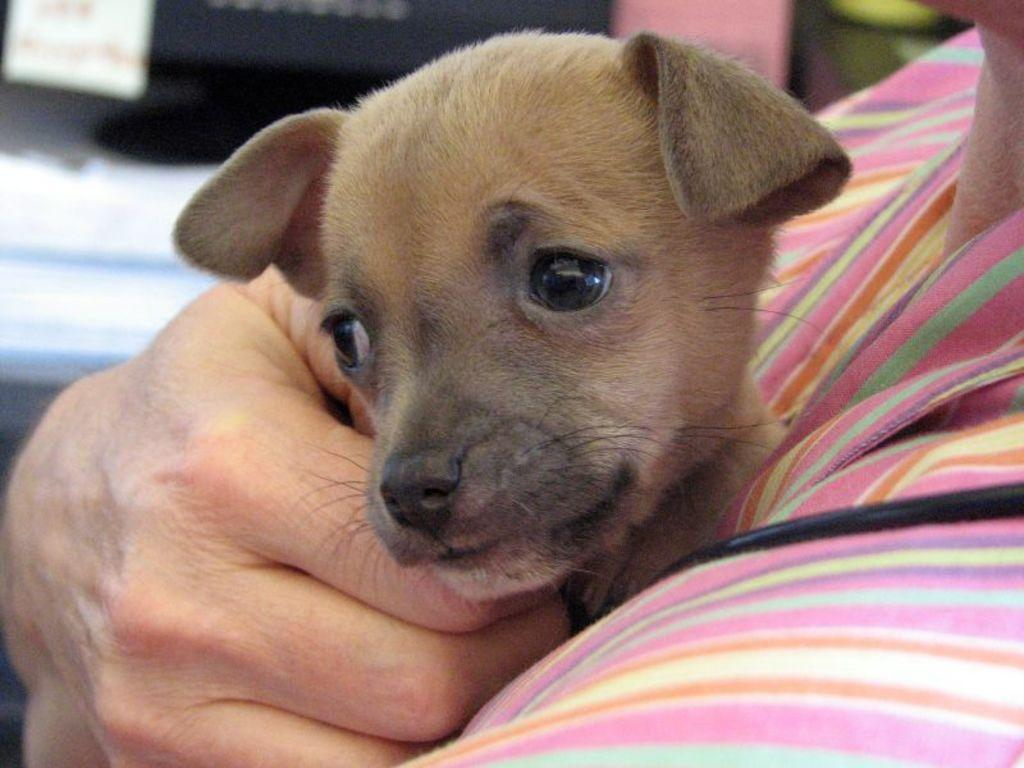What is the main subject of the image? There is a person in the image. What is the person doing in the image? The person is holding an animal. What type of chair is visible in the image? There is no chair present in the image. What level of pain is the person experiencing in the image? There is no indication of pain in the image; the person is simply holding an animal. 